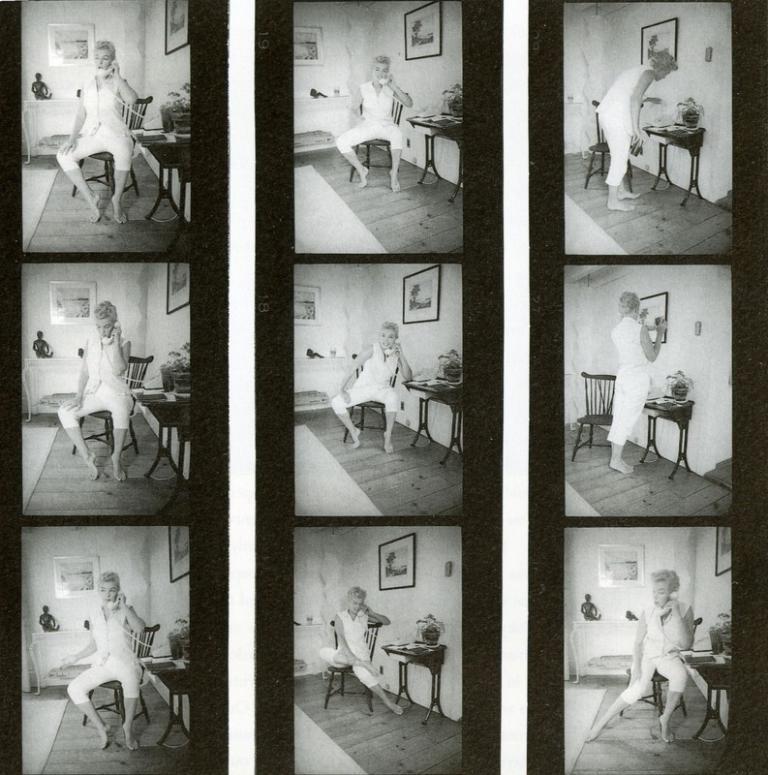Please provide a concise description of this image. This picture is the college of nine images in which the person is standing, sitting and talking on the phone and there are frames on the wall and there is a table which is black in colour on the right side in each images and on the table there is a flower vase. The image on the bottom right, there is an object in the background which is black in colour and on the bottom left there is an object which is black in colour in the background. 